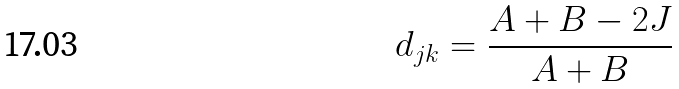Convert formula to latex. <formula><loc_0><loc_0><loc_500><loc_500>d _ { j k } = \frac { A + B - 2 J } { A + B }</formula> 